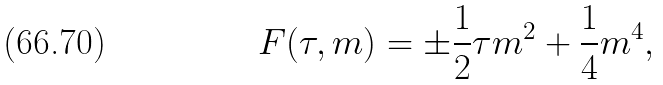<formula> <loc_0><loc_0><loc_500><loc_500>F ( \tau , m ) = \pm \frac { 1 } { 2 } \tau m ^ { 2 } + \frac { 1 } { 4 } m ^ { 4 } ,</formula> 